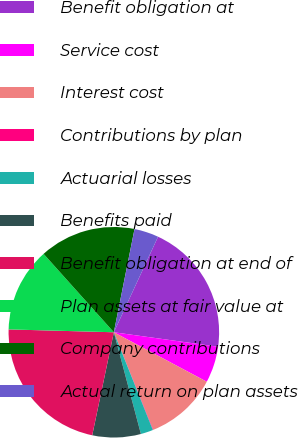<chart> <loc_0><loc_0><loc_500><loc_500><pie_chart><fcel>Benefit obligation at<fcel>Service cost<fcel>Interest cost<fcel>Contributions by plan<fcel>Actuarial losses<fcel>Benefits paid<fcel>Benefit obligation at end of<fcel>Plan assets at fair value at<fcel>Company contributions<fcel>Actual return on plan assets<nl><fcel>20.3%<fcel>5.59%<fcel>11.1%<fcel>0.07%<fcel>1.91%<fcel>7.43%<fcel>22.14%<fcel>12.94%<fcel>14.78%<fcel>3.75%<nl></chart> 